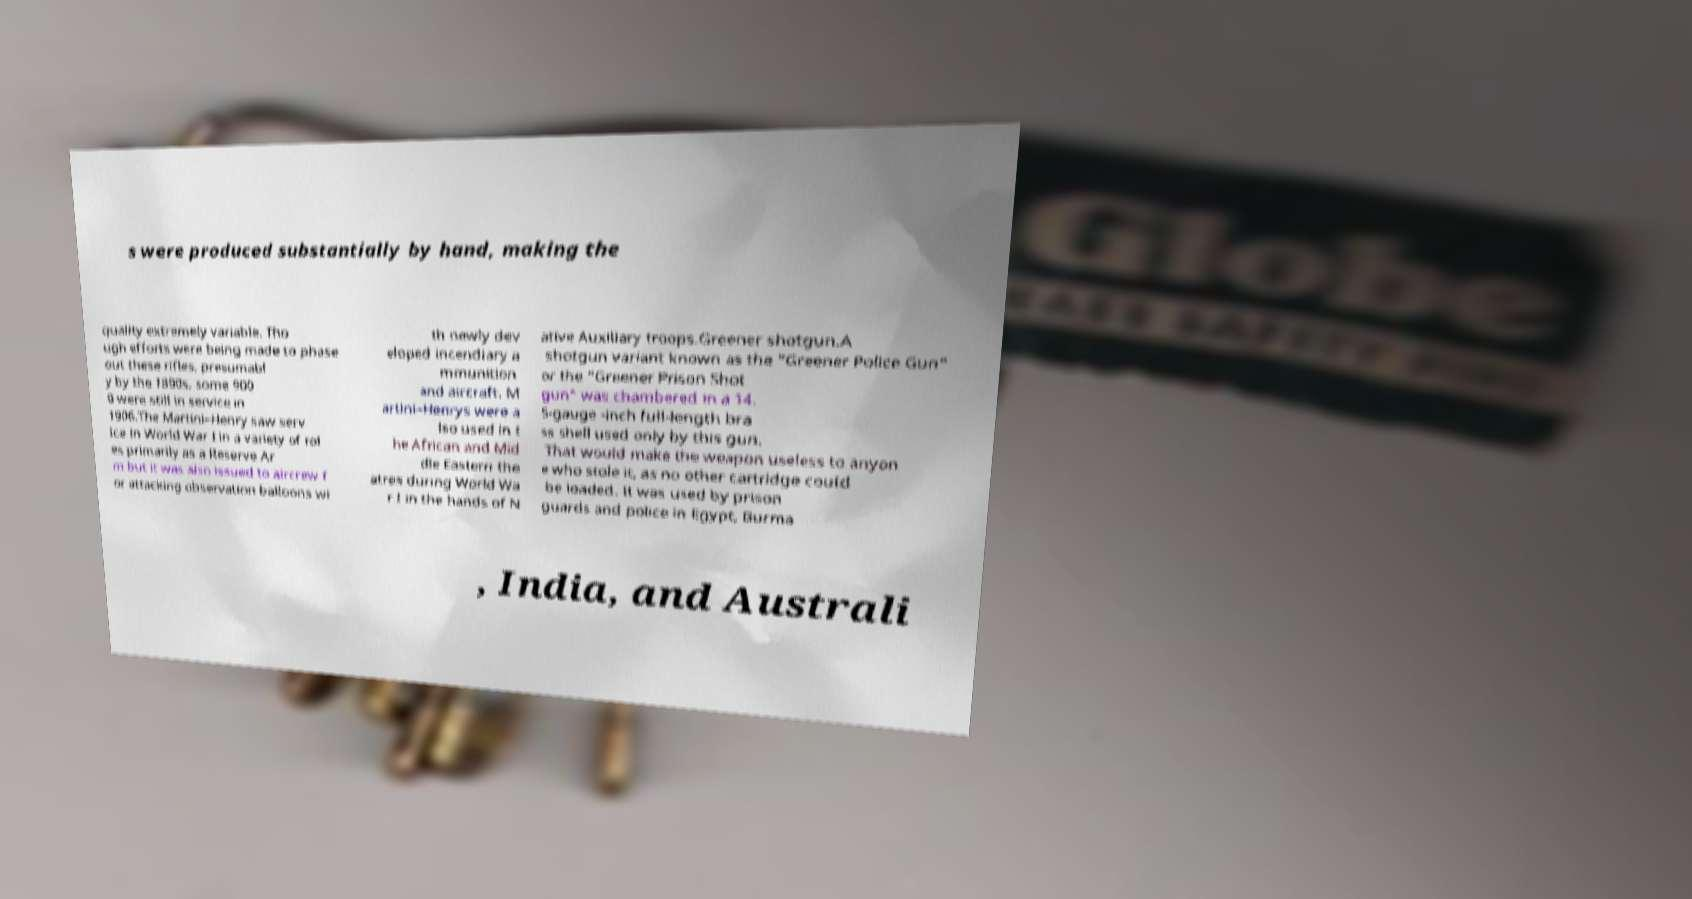Can you read and provide the text displayed in the image?This photo seems to have some interesting text. Can you extract and type it out for me? s were produced substantially by hand, making the quality extremely variable. Tho ugh efforts were being made to phase out these rifles, presumabl y by the 1890s, some 900 0 were still in service in 1906.The Martini–Henry saw serv ice in World War I in a variety of rol es primarily as a Reserve Ar m but it was also issued to aircrew f or attacking observation balloons wi th newly dev eloped incendiary a mmunition and aircraft. M artini–Henrys were a lso used in t he African and Mid dle Eastern the atres during World Wa r I in the hands of N ative Auxiliary troops.Greener shotgun.A shotgun variant known as the "Greener Police Gun" or the "Greener Prison Shot gun" was chambered in a 14. 5-gauge -inch full-length bra ss shell used only by this gun. That would make the weapon useless to anyon e who stole it, as no other cartridge could be loaded. It was used by prison guards and police in Egypt, Burma , India, and Australi 